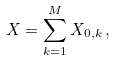Convert formula to latex. <formula><loc_0><loc_0><loc_500><loc_500>X = \sum _ { k = 1 } ^ { M } X _ { 0 , k } \, ,</formula> 